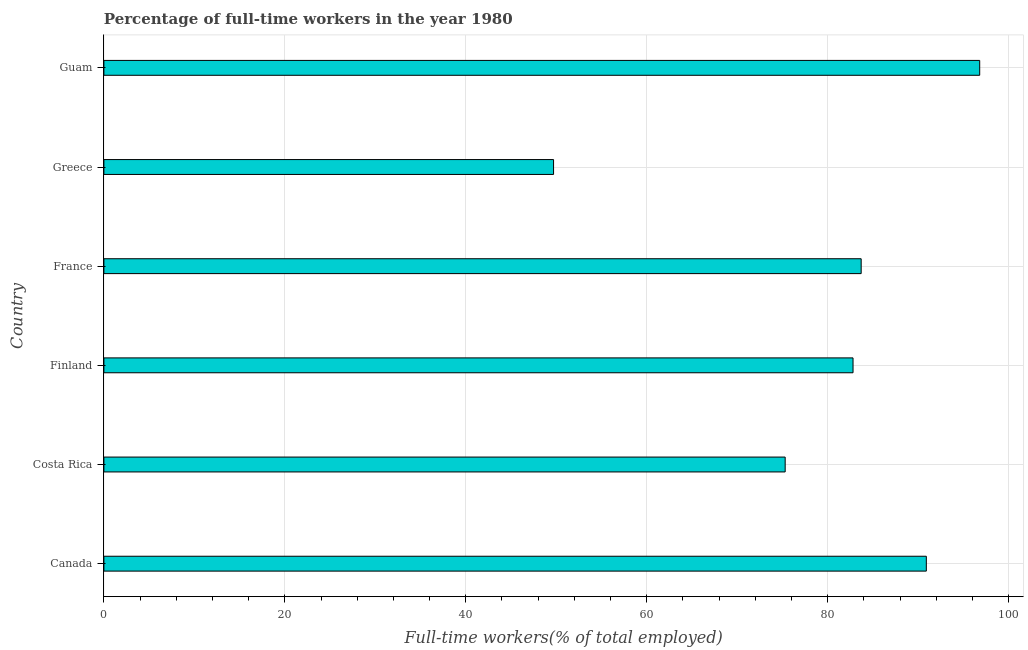What is the title of the graph?
Provide a short and direct response. Percentage of full-time workers in the year 1980. What is the label or title of the X-axis?
Offer a very short reply. Full-time workers(% of total employed). What is the label or title of the Y-axis?
Give a very brief answer. Country. What is the percentage of full-time workers in Canada?
Make the answer very short. 90.9. Across all countries, what is the maximum percentage of full-time workers?
Your answer should be compact. 96.8. Across all countries, what is the minimum percentage of full-time workers?
Offer a very short reply. 49.7. In which country was the percentage of full-time workers maximum?
Your answer should be compact. Guam. What is the sum of the percentage of full-time workers?
Provide a succinct answer. 479.2. What is the difference between the percentage of full-time workers in Costa Rica and Guam?
Provide a short and direct response. -21.5. What is the average percentage of full-time workers per country?
Make the answer very short. 79.87. What is the median percentage of full-time workers?
Your response must be concise. 83.25. What is the ratio of the percentage of full-time workers in France to that in Guam?
Offer a terse response. 0.86. What is the difference between the highest and the second highest percentage of full-time workers?
Provide a succinct answer. 5.9. Is the sum of the percentage of full-time workers in Finland and Greece greater than the maximum percentage of full-time workers across all countries?
Offer a very short reply. Yes. What is the difference between the highest and the lowest percentage of full-time workers?
Give a very brief answer. 47.1. In how many countries, is the percentage of full-time workers greater than the average percentage of full-time workers taken over all countries?
Give a very brief answer. 4. How many countries are there in the graph?
Provide a short and direct response. 6. What is the difference between two consecutive major ticks on the X-axis?
Make the answer very short. 20. Are the values on the major ticks of X-axis written in scientific E-notation?
Make the answer very short. No. What is the Full-time workers(% of total employed) of Canada?
Provide a short and direct response. 90.9. What is the Full-time workers(% of total employed) in Costa Rica?
Offer a terse response. 75.3. What is the Full-time workers(% of total employed) in Finland?
Make the answer very short. 82.8. What is the Full-time workers(% of total employed) of France?
Make the answer very short. 83.7. What is the Full-time workers(% of total employed) of Greece?
Keep it short and to the point. 49.7. What is the Full-time workers(% of total employed) of Guam?
Offer a terse response. 96.8. What is the difference between the Full-time workers(% of total employed) in Canada and France?
Your answer should be compact. 7.2. What is the difference between the Full-time workers(% of total employed) in Canada and Greece?
Give a very brief answer. 41.2. What is the difference between the Full-time workers(% of total employed) in Costa Rica and Finland?
Your response must be concise. -7.5. What is the difference between the Full-time workers(% of total employed) in Costa Rica and France?
Your response must be concise. -8.4. What is the difference between the Full-time workers(% of total employed) in Costa Rica and Greece?
Provide a succinct answer. 25.6. What is the difference between the Full-time workers(% of total employed) in Costa Rica and Guam?
Make the answer very short. -21.5. What is the difference between the Full-time workers(% of total employed) in Finland and France?
Your answer should be very brief. -0.9. What is the difference between the Full-time workers(% of total employed) in Finland and Greece?
Your answer should be compact. 33.1. What is the difference between the Full-time workers(% of total employed) in France and Greece?
Ensure brevity in your answer.  34. What is the difference between the Full-time workers(% of total employed) in France and Guam?
Offer a very short reply. -13.1. What is the difference between the Full-time workers(% of total employed) in Greece and Guam?
Give a very brief answer. -47.1. What is the ratio of the Full-time workers(% of total employed) in Canada to that in Costa Rica?
Offer a very short reply. 1.21. What is the ratio of the Full-time workers(% of total employed) in Canada to that in Finland?
Ensure brevity in your answer.  1.1. What is the ratio of the Full-time workers(% of total employed) in Canada to that in France?
Give a very brief answer. 1.09. What is the ratio of the Full-time workers(% of total employed) in Canada to that in Greece?
Your answer should be very brief. 1.83. What is the ratio of the Full-time workers(% of total employed) in Canada to that in Guam?
Provide a succinct answer. 0.94. What is the ratio of the Full-time workers(% of total employed) in Costa Rica to that in Finland?
Your answer should be very brief. 0.91. What is the ratio of the Full-time workers(% of total employed) in Costa Rica to that in Greece?
Offer a terse response. 1.51. What is the ratio of the Full-time workers(% of total employed) in Costa Rica to that in Guam?
Provide a short and direct response. 0.78. What is the ratio of the Full-time workers(% of total employed) in Finland to that in France?
Your answer should be very brief. 0.99. What is the ratio of the Full-time workers(% of total employed) in Finland to that in Greece?
Offer a very short reply. 1.67. What is the ratio of the Full-time workers(% of total employed) in Finland to that in Guam?
Offer a terse response. 0.85. What is the ratio of the Full-time workers(% of total employed) in France to that in Greece?
Offer a terse response. 1.68. What is the ratio of the Full-time workers(% of total employed) in France to that in Guam?
Your response must be concise. 0.86. What is the ratio of the Full-time workers(% of total employed) in Greece to that in Guam?
Keep it short and to the point. 0.51. 